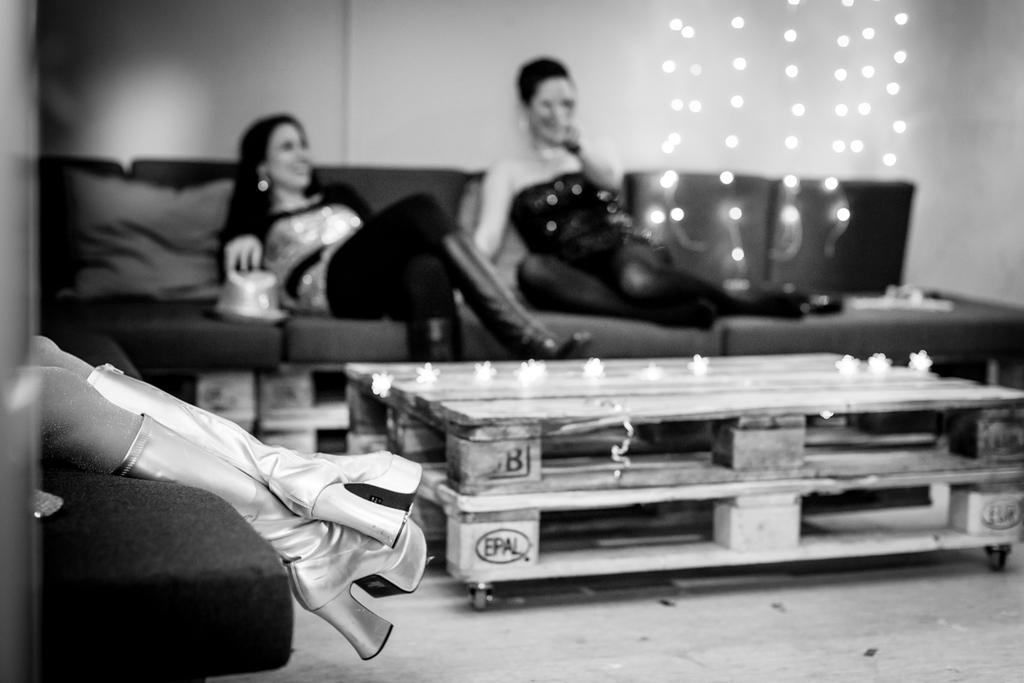What is the color scheme of the image? The image is black and white. What type of furniture can be seen in the image? There are sofas in the image. What are the people in the image doing? People are sitting on the sofas. What is located in the middle of the image? There is a table and lights in the middle of the image. What flavor of rail can be seen in the image? There is no rail present in the image, and therefore no flavor can be associated with it. 